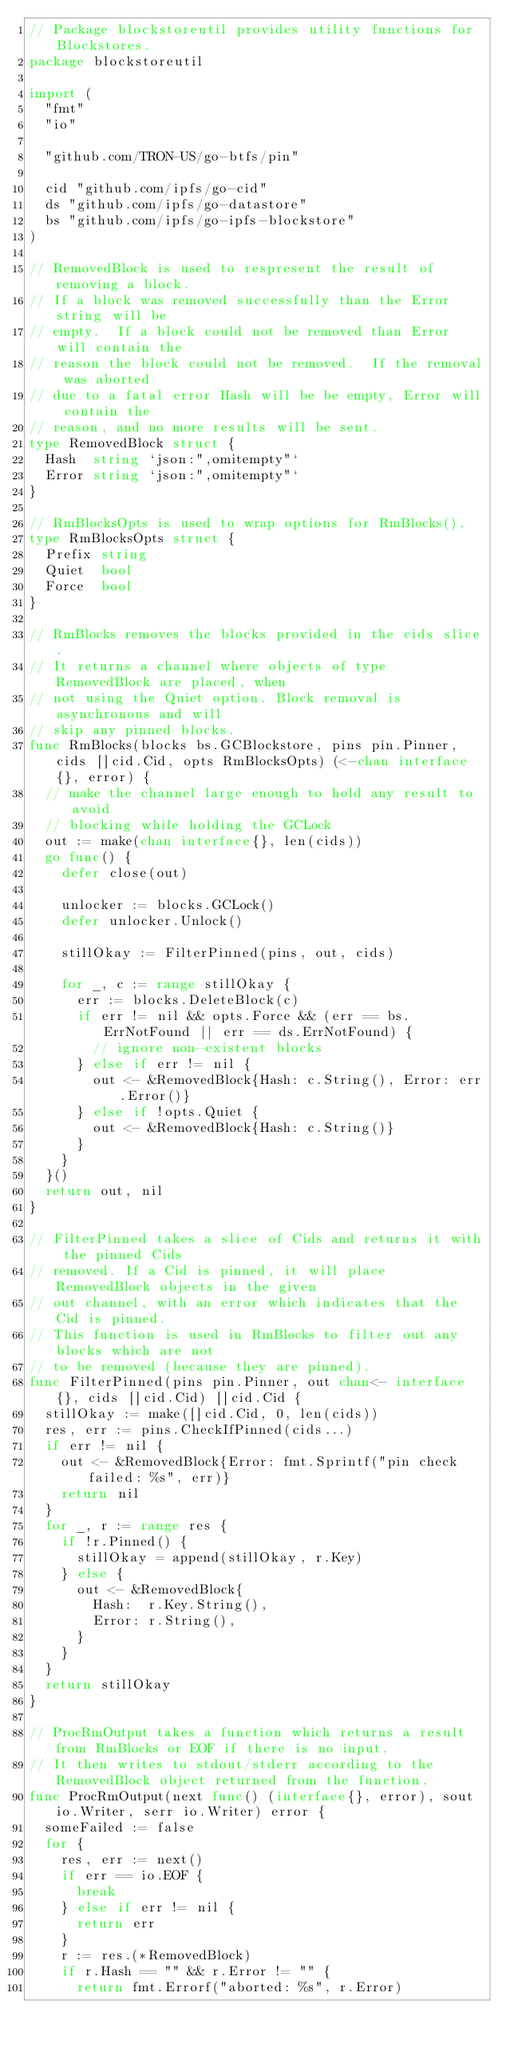Convert code to text. <code><loc_0><loc_0><loc_500><loc_500><_Go_>// Package blockstoreutil provides utility functions for Blockstores.
package blockstoreutil

import (
	"fmt"
	"io"

	"github.com/TRON-US/go-btfs/pin"

	cid "github.com/ipfs/go-cid"
	ds "github.com/ipfs/go-datastore"
	bs "github.com/ipfs/go-ipfs-blockstore"
)

// RemovedBlock is used to respresent the result of removing a block.
// If a block was removed successfully than the Error string will be
// empty.  If a block could not be removed than Error will contain the
// reason the block could not be removed.  If the removal was aborted
// due to a fatal error Hash will be be empty, Error will contain the
// reason, and no more results will be sent.
type RemovedBlock struct {
	Hash  string `json:",omitempty"`
	Error string `json:",omitempty"`
}

// RmBlocksOpts is used to wrap options for RmBlocks().
type RmBlocksOpts struct {
	Prefix string
	Quiet  bool
	Force  bool
}

// RmBlocks removes the blocks provided in the cids slice.
// It returns a channel where objects of type RemovedBlock are placed, when
// not using the Quiet option. Block removal is asynchronous and will
// skip any pinned blocks.
func RmBlocks(blocks bs.GCBlockstore, pins pin.Pinner, cids []cid.Cid, opts RmBlocksOpts) (<-chan interface{}, error) {
	// make the channel large enough to hold any result to avoid
	// blocking while holding the GCLock
	out := make(chan interface{}, len(cids))
	go func() {
		defer close(out)

		unlocker := blocks.GCLock()
		defer unlocker.Unlock()

		stillOkay := FilterPinned(pins, out, cids)

		for _, c := range stillOkay {
			err := blocks.DeleteBlock(c)
			if err != nil && opts.Force && (err == bs.ErrNotFound || err == ds.ErrNotFound) {
				// ignore non-existent blocks
			} else if err != nil {
				out <- &RemovedBlock{Hash: c.String(), Error: err.Error()}
			} else if !opts.Quiet {
				out <- &RemovedBlock{Hash: c.String()}
			}
		}
	}()
	return out, nil
}

// FilterPinned takes a slice of Cids and returns it with the pinned Cids
// removed. If a Cid is pinned, it will place RemovedBlock objects in the given
// out channel, with an error which indicates that the Cid is pinned.
// This function is used in RmBlocks to filter out any blocks which are not
// to be removed (because they are pinned).
func FilterPinned(pins pin.Pinner, out chan<- interface{}, cids []cid.Cid) []cid.Cid {
	stillOkay := make([]cid.Cid, 0, len(cids))
	res, err := pins.CheckIfPinned(cids...)
	if err != nil {
		out <- &RemovedBlock{Error: fmt.Sprintf("pin check failed: %s", err)}
		return nil
	}
	for _, r := range res {
		if !r.Pinned() {
			stillOkay = append(stillOkay, r.Key)
		} else {
			out <- &RemovedBlock{
				Hash:  r.Key.String(),
				Error: r.String(),
			}
		}
	}
	return stillOkay
}

// ProcRmOutput takes a function which returns a result from RmBlocks or EOF if there is no input.
// It then writes to stdout/stderr according to the RemovedBlock object returned from the function.
func ProcRmOutput(next func() (interface{}, error), sout io.Writer, serr io.Writer) error {
	someFailed := false
	for {
		res, err := next()
		if err == io.EOF {
			break
		} else if err != nil {
			return err
		}
		r := res.(*RemovedBlock)
		if r.Hash == "" && r.Error != "" {
			return fmt.Errorf("aborted: %s", r.Error)</code> 